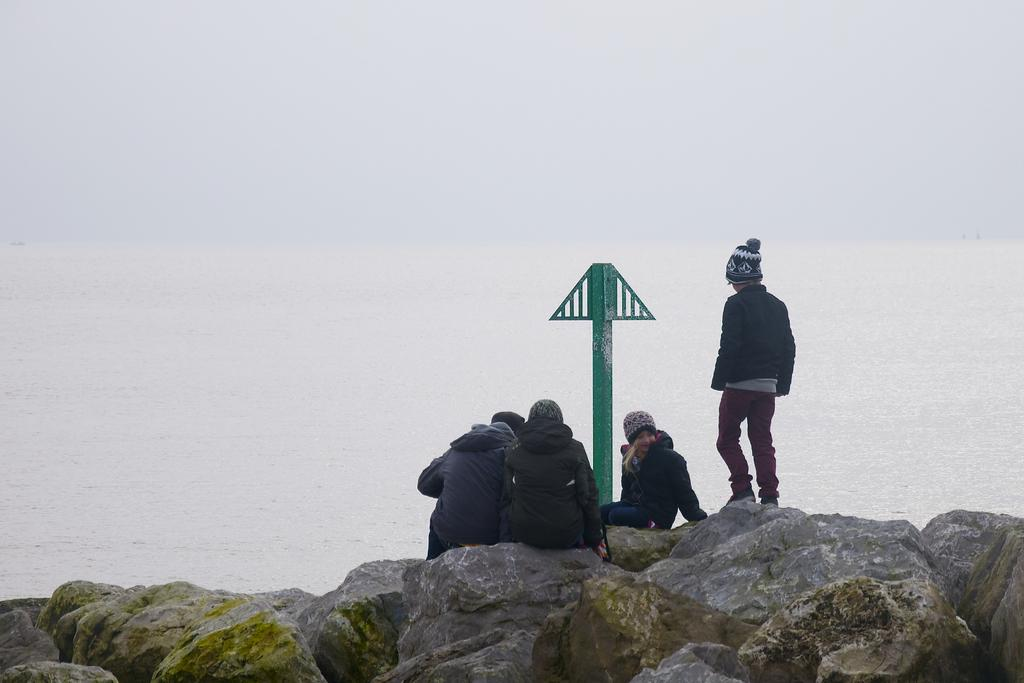How many people are sitting on the rocks in the image? There are three persons sitting on the rocks in the image. What is the position of the fourth person in the image? There is one person standing in the image. Can you describe an object with a specific color in the image? Yes, there is a green color pole in the image. What can be seen in the background of the image? There is a river in the background of the image. What type of toothbrush is the fireman using in the image? There is no fireman or toothbrush present in the image. Can you tell me how many cables are connected to the green pole in the image? There is no mention of cables connected to the green pole in the image; only the pole itself is described. 